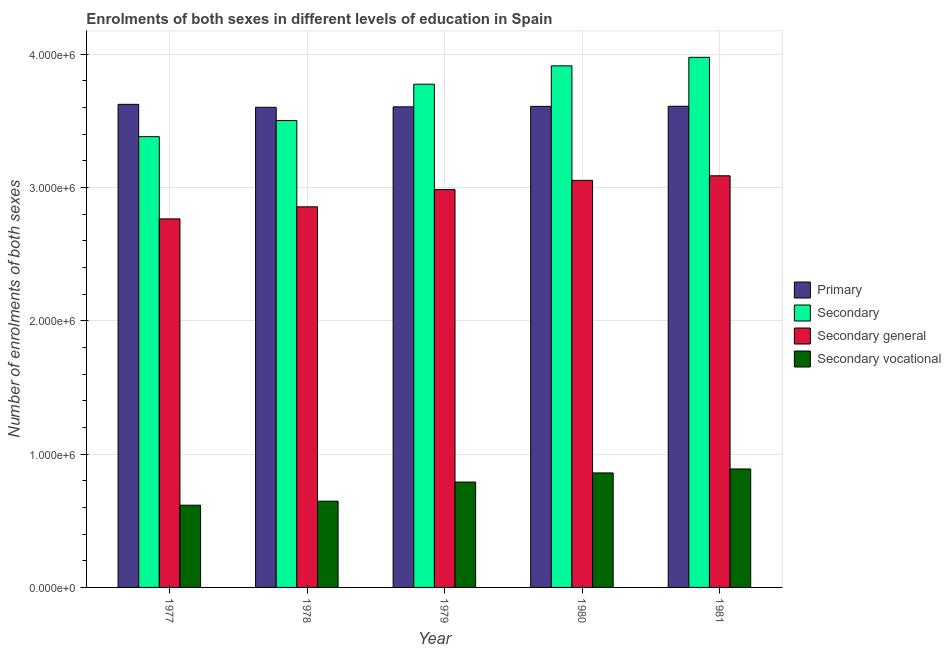How many groups of bars are there?
Offer a very short reply. 5. Are the number of bars on each tick of the X-axis equal?
Give a very brief answer. Yes. How many bars are there on the 4th tick from the right?
Your response must be concise. 4. What is the number of enrolments in secondary vocational education in 1980?
Keep it short and to the point. 8.59e+05. Across all years, what is the maximum number of enrolments in secondary vocational education?
Provide a short and direct response. 8.89e+05. Across all years, what is the minimum number of enrolments in primary education?
Provide a short and direct response. 3.60e+06. What is the total number of enrolments in secondary general education in the graph?
Your answer should be very brief. 1.47e+07. What is the difference between the number of enrolments in primary education in 1978 and that in 1981?
Give a very brief answer. -7675. What is the difference between the number of enrolments in primary education in 1979 and the number of enrolments in secondary education in 1981?
Provide a succinct answer. -4299. What is the average number of enrolments in secondary general education per year?
Offer a very short reply. 2.95e+06. In the year 1977, what is the difference between the number of enrolments in secondary general education and number of enrolments in secondary education?
Ensure brevity in your answer.  0. What is the ratio of the number of enrolments in secondary education in 1977 to that in 1980?
Keep it short and to the point. 0.86. What is the difference between the highest and the second highest number of enrolments in secondary vocational education?
Offer a terse response. 2.97e+04. What is the difference between the highest and the lowest number of enrolments in secondary education?
Give a very brief answer. 5.95e+05. Is it the case that in every year, the sum of the number of enrolments in secondary general education and number of enrolments in secondary vocational education is greater than the sum of number of enrolments in primary education and number of enrolments in secondary education?
Offer a very short reply. No. What does the 1st bar from the left in 1977 represents?
Offer a terse response. Primary. What does the 2nd bar from the right in 1977 represents?
Your answer should be very brief. Secondary general. How many bars are there?
Offer a terse response. 20. Does the graph contain grids?
Give a very brief answer. Yes. How many legend labels are there?
Give a very brief answer. 4. How are the legend labels stacked?
Ensure brevity in your answer.  Vertical. What is the title of the graph?
Ensure brevity in your answer.  Enrolments of both sexes in different levels of education in Spain. What is the label or title of the Y-axis?
Offer a very short reply. Number of enrolments of both sexes. What is the Number of enrolments of both sexes in Primary in 1977?
Your answer should be very brief. 3.62e+06. What is the Number of enrolments of both sexes of Secondary in 1977?
Your answer should be very brief. 3.38e+06. What is the Number of enrolments of both sexes in Secondary general in 1977?
Ensure brevity in your answer.  2.76e+06. What is the Number of enrolments of both sexes in Secondary vocational in 1977?
Offer a very short reply. 6.17e+05. What is the Number of enrolments of both sexes of Primary in 1978?
Offer a terse response. 3.60e+06. What is the Number of enrolments of both sexes of Secondary in 1978?
Your response must be concise. 3.50e+06. What is the Number of enrolments of both sexes in Secondary general in 1978?
Ensure brevity in your answer.  2.86e+06. What is the Number of enrolments of both sexes of Secondary vocational in 1978?
Your answer should be very brief. 6.47e+05. What is the Number of enrolments of both sexes of Primary in 1979?
Provide a succinct answer. 3.61e+06. What is the Number of enrolments of both sexes of Secondary in 1979?
Ensure brevity in your answer.  3.78e+06. What is the Number of enrolments of both sexes in Secondary general in 1979?
Ensure brevity in your answer.  2.98e+06. What is the Number of enrolments of both sexes of Secondary vocational in 1979?
Provide a short and direct response. 7.91e+05. What is the Number of enrolments of both sexes of Primary in 1980?
Offer a very short reply. 3.61e+06. What is the Number of enrolments of both sexes in Secondary in 1980?
Make the answer very short. 3.91e+06. What is the Number of enrolments of both sexes in Secondary general in 1980?
Make the answer very short. 3.05e+06. What is the Number of enrolments of both sexes in Secondary vocational in 1980?
Make the answer very short. 8.59e+05. What is the Number of enrolments of both sexes in Primary in 1981?
Keep it short and to the point. 3.61e+06. What is the Number of enrolments of both sexes of Secondary in 1981?
Keep it short and to the point. 3.98e+06. What is the Number of enrolments of both sexes of Secondary general in 1981?
Offer a very short reply. 3.09e+06. What is the Number of enrolments of both sexes in Secondary vocational in 1981?
Offer a terse response. 8.89e+05. Across all years, what is the maximum Number of enrolments of both sexes of Primary?
Your answer should be compact. 3.62e+06. Across all years, what is the maximum Number of enrolments of both sexes of Secondary?
Make the answer very short. 3.98e+06. Across all years, what is the maximum Number of enrolments of both sexes in Secondary general?
Your response must be concise. 3.09e+06. Across all years, what is the maximum Number of enrolments of both sexes of Secondary vocational?
Make the answer very short. 8.89e+05. Across all years, what is the minimum Number of enrolments of both sexes of Primary?
Your answer should be compact. 3.60e+06. Across all years, what is the minimum Number of enrolments of both sexes in Secondary?
Your answer should be compact. 3.38e+06. Across all years, what is the minimum Number of enrolments of both sexes of Secondary general?
Provide a short and direct response. 2.76e+06. Across all years, what is the minimum Number of enrolments of both sexes of Secondary vocational?
Provide a short and direct response. 6.17e+05. What is the total Number of enrolments of both sexes of Primary in the graph?
Your answer should be very brief. 1.80e+07. What is the total Number of enrolments of both sexes in Secondary in the graph?
Your answer should be very brief. 1.85e+07. What is the total Number of enrolments of both sexes in Secondary general in the graph?
Provide a short and direct response. 1.47e+07. What is the total Number of enrolments of both sexes of Secondary vocational in the graph?
Make the answer very short. 3.80e+06. What is the difference between the Number of enrolments of both sexes of Primary in 1977 and that in 1978?
Ensure brevity in your answer.  2.22e+04. What is the difference between the Number of enrolments of both sexes in Secondary in 1977 and that in 1978?
Offer a very short reply. -1.21e+05. What is the difference between the Number of enrolments of both sexes of Secondary general in 1977 and that in 1978?
Ensure brevity in your answer.  -9.05e+04. What is the difference between the Number of enrolments of both sexes in Secondary vocational in 1977 and that in 1978?
Your answer should be very brief. -3.03e+04. What is the difference between the Number of enrolments of both sexes of Primary in 1977 and that in 1979?
Ensure brevity in your answer.  1.88e+04. What is the difference between the Number of enrolments of both sexes in Secondary in 1977 and that in 1979?
Give a very brief answer. -3.94e+05. What is the difference between the Number of enrolments of both sexes of Secondary general in 1977 and that in 1979?
Offer a terse response. -2.20e+05. What is the difference between the Number of enrolments of both sexes of Secondary vocational in 1977 and that in 1979?
Ensure brevity in your answer.  -1.74e+05. What is the difference between the Number of enrolments of both sexes in Primary in 1977 and that in 1980?
Give a very brief answer. 1.53e+04. What is the difference between the Number of enrolments of both sexes of Secondary in 1977 and that in 1980?
Provide a succinct answer. -5.31e+05. What is the difference between the Number of enrolments of both sexes of Secondary general in 1977 and that in 1980?
Your response must be concise. -2.89e+05. What is the difference between the Number of enrolments of both sexes of Secondary vocational in 1977 and that in 1980?
Offer a terse response. -2.42e+05. What is the difference between the Number of enrolments of both sexes in Primary in 1977 and that in 1981?
Your answer should be compact. 1.45e+04. What is the difference between the Number of enrolments of both sexes in Secondary in 1977 and that in 1981?
Make the answer very short. -5.95e+05. What is the difference between the Number of enrolments of both sexes of Secondary general in 1977 and that in 1981?
Make the answer very short. -3.23e+05. What is the difference between the Number of enrolments of both sexes of Secondary vocational in 1977 and that in 1981?
Keep it short and to the point. -2.72e+05. What is the difference between the Number of enrolments of both sexes of Primary in 1978 and that in 1979?
Offer a very short reply. -3376. What is the difference between the Number of enrolments of both sexes of Secondary in 1978 and that in 1979?
Keep it short and to the point. -2.73e+05. What is the difference between the Number of enrolments of both sexes of Secondary general in 1978 and that in 1979?
Your answer should be compact. -1.29e+05. What is the difference between the Number of enrolments of both sexes of Secondary vocational in 1978 and that in 1979?
Offer a very short reply. -1.43e+05. What is the difference between the Number of enrolments of both sexes in Primary in 1978 and that in 1980?
Keep it short and to the point. -6906. What is the difference between the Number of enrolments of both sexes of Secondary in 1978 and that in 1980?
Provide a succinct answer. -4.10e+05. What is the difference between the Number of enrolments of both sexes of Secondary general in 1978 and that in 1980?
Provide a short and direct response. -1.99e+05. What is the difference between the Number of enrolments of both sexes of Secondary vocational in 1978 and that in 1980?
Provide a short and direct response. -2.12e+05. What is the difference between the Number of enrolments of both sexes in Primary in 1978 and that in 1981?
Provide a short and direct response. -7675. What is the difference between the Number of enrolments of both sexes in Secondary in 1978 and that in 1981?
Your answer should be compact. -4.74e+05. What is the difference between the Number of enrolments of both sexes of Secondary general in 1978 and that in 1981?
Ensure brevity in your answer.  -2.33e+05. What is the difference between the Number of enrolments of both sexes in Secondary vocational in 1978 and that in 1981?
Your response must be concise. -2.41e+05. What is the difference between the Number of enrolments of both sexes in Primary in 1979 and that in 1980?
Provide a succinct answer. -3530. What is the difference between the Number of enrolments of both sexes in Secondary in 1979 and that in 1980?
Provide a succinct answer. -1.38e+05. What is the difference between the Number of enrolments of both sexes in Secondary general in 1979 and that in 1980?
Ensure brevity in your answer.  -6.92e+04. What is the difference between the Number of enrolments of both sexes in Secondary vocational in 1979 and that in 1980?
Offer a very short reply. -6.84e+04. What is the difference between the Number of enrolments of both sexes of Primary in 1979 and that in 1981?
Your answer should be very brief. -4299. What is the difference between the Number of enrolments of both sexes of Secondary in 1979 and that in 1981?
Your answer should be very brief. -2.02e+05. What is the difference between the Number of enrolments of both sexes of Secondary general in 1979 and that in 1981?
Your response must be concise. -1.03e+05. What is the difference between the Number of enrolments of both sexes in Secondary vocational in 1979 and that in 1981?
Provide a short and direct response. -9.81e+04. What is the difference between the Number of enrolments of both sexes in Primary in 1980 and that in 1981?
Offer a very short reply. -769. What is the difference between the Number of enrolments of both sexes of Secondary in 1980 and that in 1981?
Your answer should be very brief. -6.40e+04. What is the difference between the Number of enrolments of both sexes of Secondary general in 1980 and that in 1981?
Keep it short and to the point. -3.42e+04. What is the difference between the Number of enrolments of both sexes in Secondary vocational in 1980 and that in 1981?
Provide a short and direct response. -2.97e+04. What is the difference between the Number of enrolments of both sexes of Primary in 1977 and the Number of enrolments of both sexes of Secondary in 1978?
Offer a very short reply. 1.22e+05. What is the difference between the Number of enrolments of both sexes in Primary in 1977 and the Number of enrolments of both sexes in Secondary general in 1978?
Make the answer very short. 7.69e+05. What is the difference between the Number of enrolments of both sexes of Primary in 1977 and the Number of enrolments of both sexes of Secondary vocational in 1978?
Make the answer very short. 2.98e+06. What is the difference between the Number of enrolments of both sexes in Secondary in 1977 and the Number of enrolments of both sexes in Secondary general in 1978?
Give a very brief answer. 5.26e+05. What is the difference between the Number of enrolments of both sexes of Secondary in 1977 and the Number of enrolments of both sexes of Secondary vocational in 1978?
Ensure brevity in your answer.  2.73e+06. What is the difference between the Number of enrolments of both sexes in Secondary general in 1977 and the Number of enrolments of both sexes in Secondary vocational in 1978?
Give a very brief answer. 2.12e+06. What is the difference between the Number of enrolments of both sexes of Primary in 1977 and the Number of enrolments of both sexes of Secondary in 1979?
Your response must be concise. -1.51e+05. What is the difference between the Number of enrolments of both sexes in Primary in 1977 and the Number of enrolments of both sexes in Secondary general in 1979?
Your response must be concise. 6.40e+05. What is the difference between the Number of enrolments of both sexes in Primary in 1977 and the Number of enrolments of both sexes in Secondary vocational in 1979?
Offer a very short reply. 2.83e+06. What is the difference between the Number of enrolments of both sexes of Secondary in 1977 and the Number of enrolments of both sexes of Secondary general in 1979?
Your response must be concise. 3.97e+05. What is the difference between the Number of enrolments of both sexes of Secondary in 1977 and the Number of enrolments of both sexes of Secondary vocational in 1979?
Your response must be concise. 2.59e+06. What is the difference between the Number of enrolments of both sexes in Secondary general in 1977 and the Number of enrolments of both sexes in Secondary vocational in 1979?
Your answer should be very brief. 1.97e+06. What is the difference between the Number of enrolments of both sexes of Primary in 1977 and the Number of enrolments of both sexes of Secondary in 1980?
Offer a very short reply. -2.89e+05. What is the difference between the Number of enrolments of both sexes of Primary in 1977 and the Number of enrolments of both sexes of Secondary general in 1980?
Offer a terse response. 5.70e+05. What is the difference between the Number of enrolments of both sexes in Primary in 1977 and the Number of enrolments of both sexes in Secondary vocational in 1980?
Provide a short and direct response. 2.77e+06. What is the difference between the Number of enrolments of both sexes of Secondary in 1977 and the Number of enrolments of both sexes of Secondary general in 1980?
Make the answer very short. 3.28e+05. What is the difference between the Number of enrolments of both sexes in Secondary in 1977 and the Number of enrolments of both sexes in Secondary vocational in 1980?
Make the answer very short. 2.52e+06. What is the difference between the Number of enrolments of both sexes of Secondary general in 1977 and the Number of enrolments of both sexes of Secondary vocational in 1980?
Your answer should be compact. 1.91e+06. What is the difference between the Number of enrolments of both sexes of Primary in 1977 and the Number of enrolments of both sexes of Secondary in 1981?
Keep it short and to the point. -3.53e+05. What is the difference between the Number of enrolments of both sexes in Primary in 1977 and the Number of enrolments of both sexes in Secondary general in 1981?
Offer a terse response. 5.36e+05. What is the difference between the Number of enrolments of both sexes of Primary in 1977 and the Number of enrolments of both sexes of Secondary vocational in 1981?
Offer a very short reply. 2.74e+06. What is the difference between the Number of enrolments of both sexes in Secondary in 1977 and the Number of enrolments of both sexes in Secondary general in 1981?
Your answer should be compact. 2.94e+05. What is the difference between the Number of enrolments of both sexes of Secondary in 1977 and the Number of enrolments of both sexes of Secondary vocational in 1981?
Your answer should be very brief. 2.49e+06. What is the difference between the Number of enrolments of both sexes of Secondary general in 1977 and the Number of enrolments of both sexes of Secondary vocational in 1981?
Your response must be concise. 1.88e+06. What is the difference between the Number of enrolments of both sexes in Primary in 1978 and the Number of enrolments of both sexes in Secondary in 1979?
Offer a very short reply. -1.73e+05. What is the difference between the Number of enrolments of both sexes in Primary in 1978 and the Number of enrolments of both sexes in Secondary general in 1979?
Ensure brevity in your answer.  6.17e+05. What is the difference between the Number of enrolments of both sexes of Primary in 1978 and the Number of enrolments of both sexes of Secondary vocational in 1979?
Provide a short and direct response. 2.81e+06. What is the difference between the Number of enrolments of both sexes of Secondary in 1978 and the Number of enrolments of both sexes of Secondary general in 1979?
Ensure brevity in your answer.  5.18e+05. What is the difference between the Number of enrolments of both sexes in Secondary in 1978 and the Number of enrolments of both sexes in Secondary vocational in 1979?
Your response must be concise. 2.71e+06. What is the difference between the Number of enrolments of both sexes of Secondary general in 1978 and the Number of enrolments of both sexes of Secondary vocational in 1979?
Offer a terse response. 2.06e+06. What is the difference between the Number of enrolments of both sexes in Primary in 1978 and the Number of enrolments of both sexes in Secondary in 1980?
Your answer should be compact. -3.11e+05. What is the difference between the Number of enrolments of both sexes of Primary in 1978 and the Number of enrolments of both sexes of Secondary general in 1980?
Make the answer very short. 5.48e+05. What is the difference between the Number of enrolments of both sexes of Primary in 1978 and the Number of enrolments of both sexes of Secondary vocational in 1980?
Your answer should be compact. 2.74e+06. What is the difference between the Number of enrolments of both sexes in Secondary in 1978 and the Number of enrolments of both sexes in Secondary general in 1980?
Keep it short and to the point. 4.49e+05. What is the difference between the Number of enrolments of both sexes of Secondary in 1978 and the Number of enrolments of both sexes of Secondary vocational in 1980?
Your response must be concise. 2.64e+06. What is the difference between the Number of enrolments of both sexes of Secondary general in 1978 and the Number of enrolments of both sexes of Secondary vocational in 1980?
Offer a very short reply. 2.00e+06. What is the difference between the Number of enrolments of both sexes of Primary in 1978 and the Number of enrolments of both sexes of Secondary in 1981?
Offer a terse response. -3.75e+05. What is the difference between the Number of enrolments of both sexes in Primary in 1978 and the Number of enrolments of both sexes in Secondary general in 1981?
Your response must be concise. 5.14e+05. What is the difference between the Number of enrolments of both sexes in Primary in 1978 and the Number of enrolments of both sexes in Secondary vocational in 1981?
Give a very brief answer. 2.71e+06. What is the difference between the Number of enrolments of both sexes in Secondary in 1978 and the Number of enrolments of both sexes in Secondary general in 1981?
Offer a terse response. 4.14e+05. What is the difference between the Number of enrolments of both sexes in Secondary in 1978 and the Number of enrolments of both sexes in Secondary vocational in 1981?
Your answer should be compact. 2.61e+06. What is the difference between the Number of enrolments of both sexes of Secondary general in 1978 and the Number of enrolments of both sexes of Secondary vocational in 1981?
Provide a short and direct response. 1.97e+06. What is the difference between the Number of enrolments of both sexes of Primary in 1979 and the Number of enrolments of both sexes of Secondary in 1980?
Provide a succinct answer. -3.07e+05. What is the difference between the Number of enrolments of both sexes of Primary in 1979 and the Number of enrolments of both sexes of Secondary general in 1980?
Your answer should be compact. 5.52e+05. What is the difference between the Number of enrolments of both sexes of Primary in 1979 and the Number of enrolments of both sexes of Secondary vocational in 1980?
Keep it short and to the point. 2.75e+06. What is the difference between the Number of enrolments of both sexes of Secondary in 1979 and the Number of enrolments of both sexes of Secondary general in 1980?
Provide a short and direct response. 7.21e+05. What is the difference between the Number of enrolments of both sexes of Secondary in 1979 and the Number of enrolments of both sexes of Secondary vocational in 1980?
Offer a very short reply. 2.92e+06. What is the difference between the Number of enrolments of both sexes of Secondary general in 1979 and the Number of enrolments of both sexes of Secondary vocational in 1980?
Your response must be concise. 2.13e+06. What is the difference between the Number of enrolments of both sexes of Primary in 1979 and the Number of enrolments of both sexes of Secondary in 1981?
Offer a terse response. -3.71e+05. What is the difference between the Number of enrolments of both sexes in Primary in 1979 and the Number of enrolments of both sexes in Secondary general in 1981?
Your response must be concise. 5.17e+05. What is the difference between the Number of enrolments of both sexes in Primary in 1979 and the Number of enrolments of both sexes in Secondary vocational in 1981?
Your response must be concise. 2.72e+06. What is the difference between the Number of enrolments of both sexes of Secondary in 1979 and the Number of enrolments of both sexes of Secondary general in 1981?
Keep it short and to the point. 6.87e+05. What is the difference between the Number of enrolments of both sexes in Secondary in 1979 and the Number of enrolments of both sexes in Secondary vocational in 1981?
Offer a terse response. 2.89e+06. What is the difference between the Number of enrolments of both sexes of Secondary general in 1979 and the Number of enrolments of both sexes of Secondary vocational in 1981?
Provide a short and direct response. 2.10e+06. What is the difference between the Number of enrolments of both sexes in Primary in 1980 and the Number of enrolments of both sexes in Secondary in 1981?
Provide a short and direct response. -3.68e+05. What is the difference between the Number of enrolments of both sexes of Primary in 1980 and the Number of enrolments of both sexes of Secondary general in 1981?
Make the answer very short. 5.21e+05. What is the difference between the Number of enrolments of both sexes in Primary in 1980 and the Number of enrolments of both sexes in Secondary vocational in 1981?
Offer a very short reply. 2.72e+06. What is the difference between the Number of enrolments of both sexes of Secondary in 1980 and the Number of enrolments of both sexes of Secondary general in 1981?
Provide a short and direct response. 8.25e+05. What is the difference between the Number of enrolments of both sexes of Secondary in 1980 and the Number of enrolments of both sexes of Secondary vocational in 1981?
Keep it short and to the point. 3.02e+06. What is the difference between the Number of enrolments of both sexes in Secondary general in 1980 and the Number of enrolments of both sexes in Secondary vocational in 1981?
Your response must be concise. 2.17e+06. What is the average Number of enrolments of both sexes in Primary per year?
Give a very brief answer. 3.61e+06. What is the average Number of enrolments of both sexes of Secondary per year?
Keep it short and to the point. 3.71e+06. What is the average Number of enrolments of both sexes in Secondary general per year?
Make the answer very short. 2.95e+06. What is the average Number of enrolments of both sexes of Secondary vocational per year?
Make the answer very short. 7.60e+05. In the year 1977, what is the difference between the Number of enrolments of both sexes in Primary and Number of enrolments of both sexes in Secondary?
Offer a terse response. 2.42e+05. In the year 1977, what is the difference between the Number of enrolments of both sexes in Primary and Number of enrolments of both sexes in Secondary general?
Your response must be concise. 8.59e+05. In the year 1977, what is the difference between the Number of enrolments of both sexes of Primary and Number of enrolments of both sexes of Secondary vocational?
Ensure brevity in your answer.  3.01e+06. In the year 1977, what is the difference between the Number of enrolments of both sexes in Secondary and Number of enrolments of both sexes in Secondary general?
Make the answer very short. 6.17e+05. In the year 1977, what is the difference between the Number of enrolments of both sexes in Secondary and Number of enrolments of both sexes in Secondary vocational?
Ensure brevity in your answer.  2.76e+06. In the year 1977, what is the difference between the Number of enrolments of both sexes in Secondary general and Number of enrolments of both sexes in Secondary vocational?
Make the answer very short. 2.15e+06. In the year 1978, what is the difference between the Number of enrolments of both sexes in Primary and Number of enrolments of both sexes in Secondary?
Keep it short and to the point. 9.95e+04. In the year 1978, what is the difference between the Number of enrolments of both sexes in Primary and Number of enrolments of both sexes in Secondary general?
Your response must be concise. 7.47e+05. In the year 1978, what is the difference between the Number of enrolments of both sexes in Primary and Number of enrolments of both sexes in Secondary vocational?
Provide a succinct answer. 2.95e+06. In the year 1978, what is the difference between the Number of enrolments of both sexes in Secondary and Number of enrolments of both sexes in Secondary general?
Ensure brevity in your answer.  6.47e+05. In the year 1978, what is the difference between the Number of enrolments of both sexes of Secondary and Number of enrolments of both sexes of Secondary vocational?
Offer a very short reply. 2.86e+06. In the year 1978, what is the difference between the Number of enrolments of both sexes in Secondary general and Number of enrolments of both sexes in Secondary vocational?
Offer a very short reply. 2.21e+06. In the year 1979, what is the difference between the Number of enrolments of both sexes of Primary and Number of enrolments of both sexes of Secondary?
Offer a very short reply. -1.70e+05. In the year 1979, what is the difference between the Number of enrolments of both sexes in Primary and Number of enrolments of both sexes in Secondary general?
Offer a terse response. 6.21e+05. In the year 1979, what is the difference between the Number of enrolments of both sexes of Primary and Number of enrolments of both sexes of Secondary vocational?
Provide a short and direct response. 2.81e+06. In the year 1979, what is the difference between the Number of enrolments of both sexes in Secondary and Number of enrolments of both sexes in Secondary general?
Provide a succinct answer. 7.91e+05. In the year 1979, what is the difference between the Number of enrolments of both sexes of Secondary and Number of enrolments of both sexes of Secondary vocational?
Your response must be concise. 2.98e+06. In the year 1979, what is the difference between the Number of enrolments of both sexes of Secondary general and Number of enrolments of both sexes of Secondary vocational?
Your answer should be compact. 2.19e+06. In the year 1980, what is the difference between the Number of enrolments of both sexes in Primary and Number of enrolments of both sexes in Secondary?
Provide a short and direct response. -3.04e+05. In the year 1980, what is the difference between the Number of enrolments of both sexes of Primary and Number of enrolments of both sexes of Secondary general?
Offer a terse response. 5.55e+05. In the year 1980, what is the difference between the Number of enrolments of both sexes in Primary and Number of enrolments of both sexes in Secondary vocational?
Ensure brevity in your answer.  2.75e+06. In the year 1980, what is the difference between the Number of enrolments of both sexes of Secondary and Number of enrolments of both sexes of Secondary general?
Give a very brief answer. 8.59e+05. In the year 1980, what is the difference between the Number of enrolments of both sexes of Secondary and Number of enrolments of both sexes of Secondary vocational?
Make the answer very short. 3.05e+06. In the year 1980, what is the difference between the Number of enrolments of both sexes in Secondary general and Number of enrolments of both sexes in Secondary vocational?
Provide a succinct answer. 2.19e+06. In the year 1981, what is the difference between the Number of enrolments of both sexes of Primary and Number of enrolments of both sexes of Secondary?
Your answer should be very brief. -3.67e+05. In the year 1981, what is the difference between the Number of enrolments of both sexes in Primary and Number of enrolments of both sexes in Secondary general?
Your response must be concise. 5.22e+05. In the year 1981, what is the difference between the Number of enrolments of both sexes in Primary and Number of enrolments of both sexes in Secondary vocational?
Ensure brevity in your answer.  2.72e+06. In the year 1981, what is the difference between the Number of enrolments of both sexes in Secondary and Number of enrolments of both sexes in Secondary general?
Your response must be concise. 8.89e+05. In the year 1981, what is the difference between the Number of enrolments of both sexes of Secondary and Number of enrolments of both sexes of Secondary vocational?
Your answer should be very brief. 3.09e+06. In the year 1981, what is the difference between the Number of enrolments of both sexes of Secondary general and Number of enrolments of both sexes of Secondary vocational?
Provide a short and direct response. 2.20e+06. What is the ratio of the Number of enrolments of both sexes in Primary in 1977 to that in 1978?
Your response must be concise. 1.01. What is the ratio of the Number of enrolments of both sexes in Secondary in 1977 to that in 1978?
Your answer should be compact. 0.97. What is the ratio of the Number of enrolments of both sexes in Secondary general in 1977 to that in 1978?
Give a very brief answer. 0.97. What is the ratio of the Number of enrolments of both sexes in Secondary vocational in 1977 to that in 1978?
Make the answer very short. 0.95. What is the ratio of the Number of enrolments of both sexes in Secondary in 1977 to that in 1979?
Your answer should be compact. 0.9. What is the ratio of the Number of enrolments of both sexes of Secondary general in 1977 to that in 1979?
Make the answer very short. 0.93. What is the ratio of the Number of enrolments of both sexes of Secondary vocational in 1977 to that in 1979?
Your answer should be very brief. 0.78. What is the ratio of the Number of enrolments of both sexes of Secondary in 1977 to that in 1980?
Make the answer very short. 0.86. What is the ratio of the Number of enrolments of both sexes of Secondary general in 1977 to that in 1980?
Make the answer very short. 0.91. What is the ratio of the Number of enrolments of both sexes in Secondary vocational in 1977 to that in 1980?
Provide a short and direct response. 0.72. What is the ratio of the Number of enrolments of both sexes in Secondary in 1977 to that in 1981?
Your answer should be very brief. 0.85. What is the ratio of the Number of enrolments of both sexes in Secondary general in 1977 to that in 1981?
Keep it short and to the point. 0.9. What is the ratio of the Number of enrolments of both sexes of Secondary vocational in 1977 to that in 1981?
Offer a terse response. 0.69. What is the ratio of the Number of enrolments of both sexes in Primary in 1978 to that in 1979?
Your answer should be compact. 1. What is the ratio of the Number of enrolments of both sexes in Secondary in 1978 to that in 1979?
Keep it short and to the point. 0.93. What is the ratio of the Number of enrolments of both sexes of Secondary general in 1978 to that in 1979?
Ensure brevity in your answer.  0.96. What is the ratio of the Number of enrolments of both sexes of Secondary vocational in 1978 to that in 1979?
Provide a succinct answer. 0.82. What is the ratio of the Number of enrolments of both sexes of Secondary in 1978 to that in 1980?
Make the answer very short. 0.9. What is the ratio of the Number of enrolments of both sexes in Secondary general in 1978 to that in 1980?
Provide a short and direct response. 0.94. What is the ratio of the Number of enrolments of both sexes in Secondary vocational in 1978 to that in 1980?
Give a very brief answer. 0.75. What is the ratio of the Number of enrolments of both sexes of Primary in 1978 to that in 1981?
Your response must be concise. 1. What is the ratio of the Number of enrolments of both sexes in Secondary in 1978 to that in 1981?
Offer a terse response. 0.88. What is the ratio of the Number of enrolments of both sexes in Secondary general in 1978 to that in 1981?
Your answer should be very brief. 0.92. What is the ratio of the Number of enrolments of both sexes of Secondary vocational in 1978 to that in 1981?
Offer a terse response. 0.73. What is the ratio of the Number of enrolments of both sexes in Secondary in 1979 to that in 1980?
Give a very brief answer. 0.96. What is the ratio of the Number of enrolments of both sexes of Secondary general in 1979 to that in 1980?
Provide a short and direct response. 0.98. What is the ratio of the Number of enrolments of both sexes of Secondary vocational in 1979 to that in 1980?
Offer a terse response. 0.92. What is the ratio of the Number of enrolments of both sexes in Secondary in 1979 to that in 1981?
Ensure brevity in your answer.  0.95. What is the ratio of the Number of enrolments of both sexes of Secondary general in 1979 to that in 1981?
Offer a terse response. 0.97. What is the ratio of the Number of enrolments of both sexes in Secondary vocational in 1979 to that in 1981?
Your response must be concise. 0.89. What is the ratio of the Number of enrolments of both sexes of Secondary in 1980 to that in 1981?
Your answer should be compact. 0.98. What is the ratio of the Number of enrolments of both sexes of Secondary general in 1980 to that in 1981?
Your answer should be compact. 0.99. What is the ratio of the Number of enrolments of both sexes in Secondary vocational in 1980 to that in 1981?
Your answer should be compact. 0.97. What is the difference between the highest and the second highest Number of enrolments of both sexes of Primary?
Keep it short and to the point. 1.45e+04. What is the difference between the highest and the second highest Number of enrolments of both sexes of Secondary?
Offer a terse response. 6.40e+04. What is the difference between the highest and the second highest Number of enrolments of both sexes in Secondary general?
Provide a succinct answer. 3.42e+04. What is the difference between the highest and the second highest Number of enrolments of both sexes in Secondary vocational?
Your answer should be compact. 2.97e+04. What is the difference between the highest and the lowest Number of enrolments of both sexes of Primary?
Ensure brevity in your answer.  2.22e+04. What is the difference between the highest and the lowest Number of enrolments of both sexes of Secondary?
Your response must be concise. 5.95e+05. What is the difference between the highest and the lowest Number of enrolments of both sexes in Secondary general?
Your answer should be very brief. 3.23e+05. What is the difference between the highest and the lowest Number of enrolments of both sexes in Secondary vocational?
Offer a terse response. 2.72e+05. 